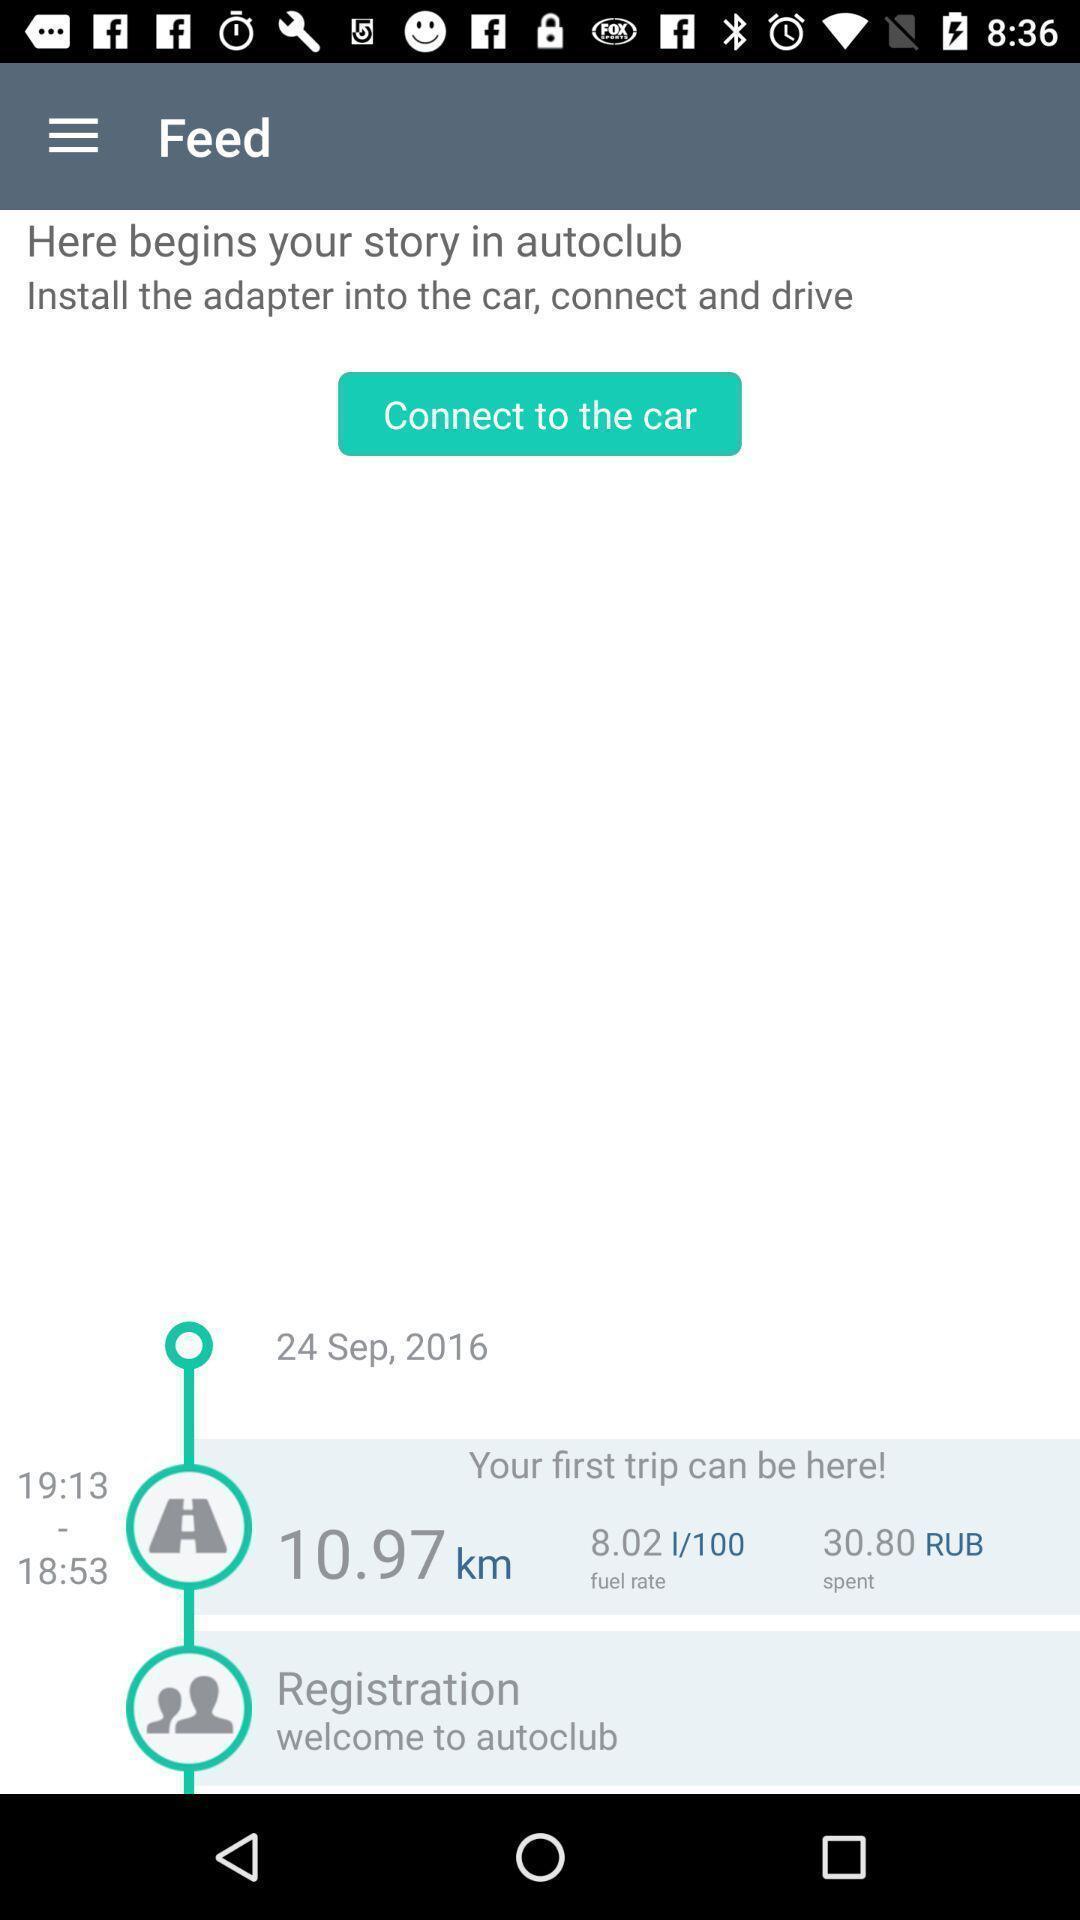What is the overall content of this screenshot? Social app for new feed. 